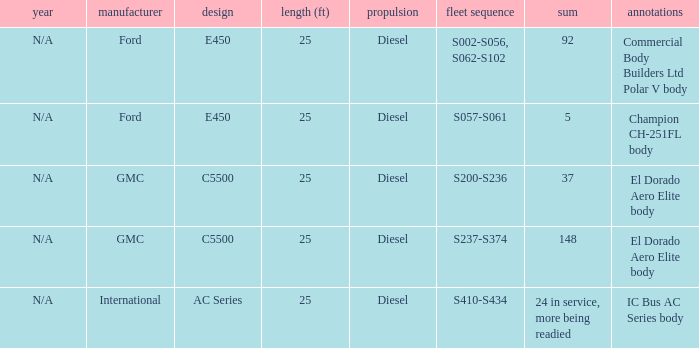Which builder has a fleet series of s057-s061? Ford. 